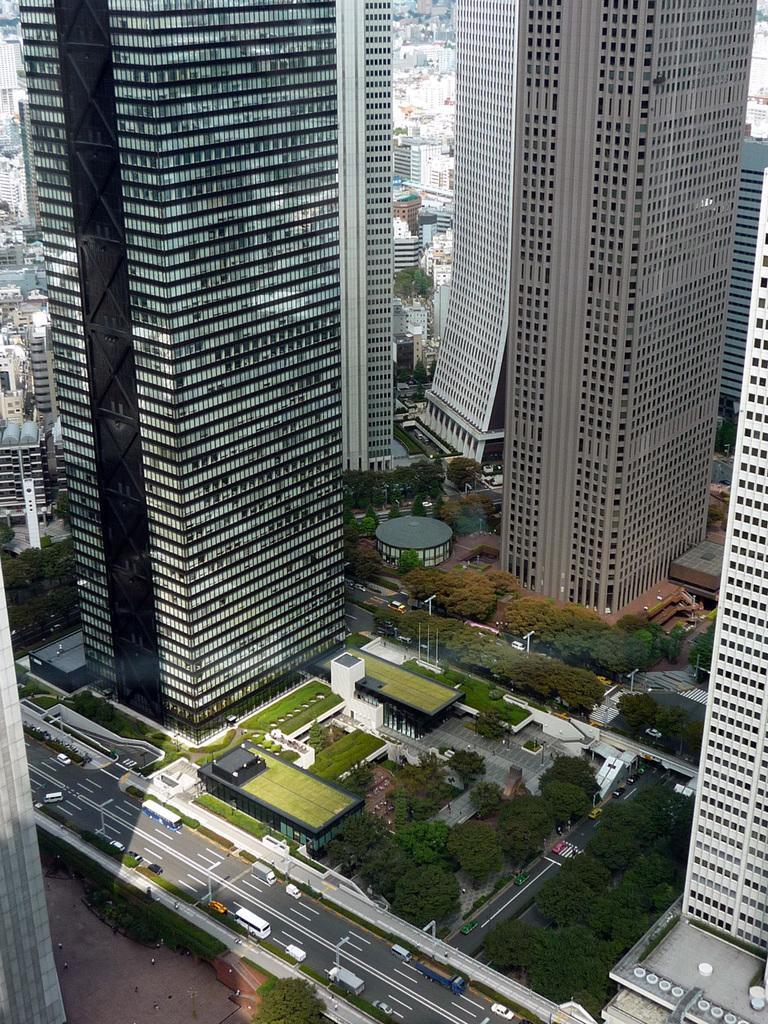How would you summarize this image in a sentence or two? This is a top view image of a city, in this image we can see buildings, roads, vehicles and trees. 